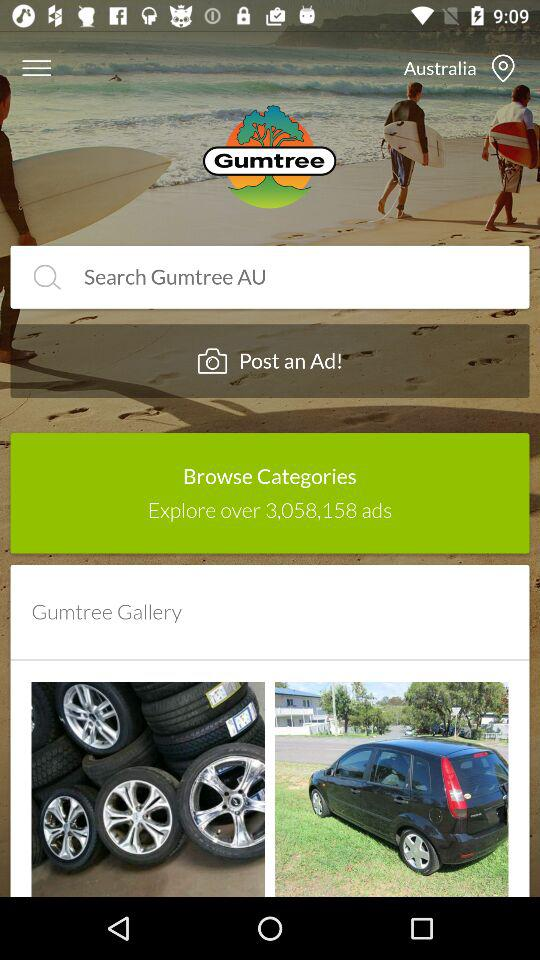What is the application name? The application name is "Gumtree". 